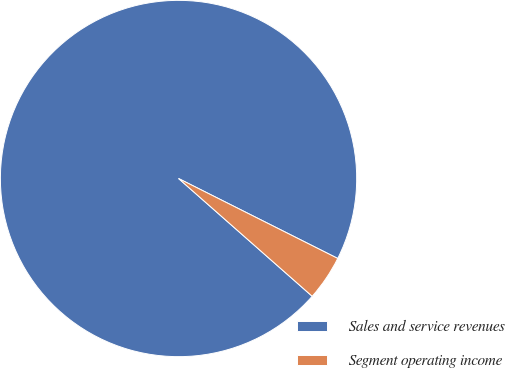Convert chart to OTSL. <chart><loc_0><loc_0><loc_500><loc_500><pie_chart><fcel>Sales and service revenues<fcel>Segment operating income<nl><fcel>95.91%<fcel>4.09%<nl></chart> 